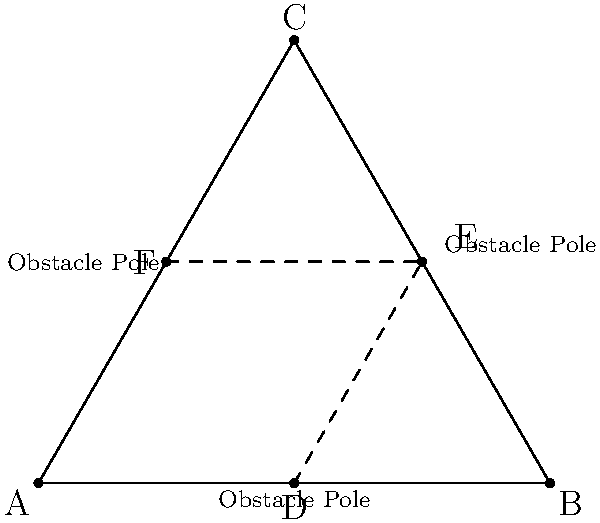In a therapy horseback riding exercise, three obstacle poles are placed in an equilateral triangle formation. If the side length of the triangle is 4 meters, what is the distance between any two obstacle poles placed at the midpoints of the triangle's sides? Let's approach this step-by-step:

1) First, we need to understand that the obstacle poles are placed at the midpoints of the equilateral triangle's sides.

2) In an equilateral triangle, the line segment joining the midpoints of two sides is parallel to the third side and half its length.

3) This means that the triangle formed by connecting the midpoints is also equilateral and similar to the original triangle.

4) The side length of the original triangle is given as 4 meters.

5) To find the side length of the inner triangle (distance between obstacle poles), we need to calculate half of the original side length:

   $\frac{4}{2} = 2$ meters

6) Therefore, the distance between any two obstacle poles is 2 meters.

This placement allows for a compact yet effective exercise layout, providing enough space for the horse and rider while maintaining a challenging course.
Answer: 2 meters 